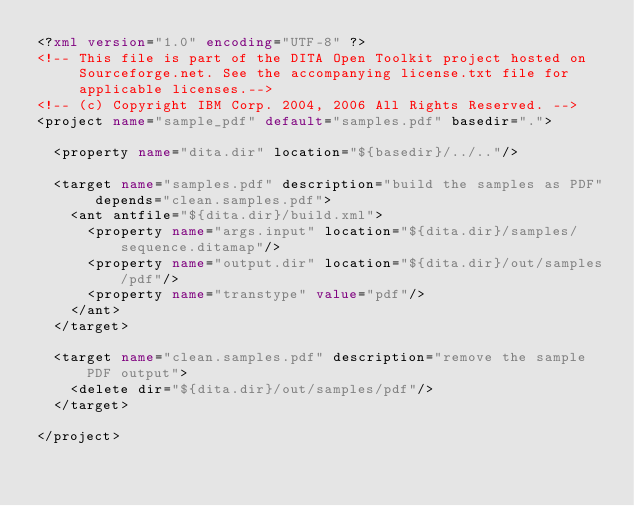Convert code to text. <code><loc_0><loc_0><loc_500><loc_500><_XML_><?xml version="1.0" encoding="UTF-8" ?>
<!-- This file is part of the DITA Open Toolkit project hosted on 
     Sourceforge.net. See the accompanying license.txt file for 
     applicable licenses.-->
<!-- (c) Copyright IBM Corp. 2004, 2006 All Rights Reserved. -->
<project name="sample_pdf" default="samples.pdf" basedir=".">
  
  <property name="dita.dir" location="${basedir}/../.."/>
  
  <target name="samples.pdf" description="build the samples as PDF" depends="clean.samples.pdf">
    <ant antfile="${dita.dir}/build.xml">
      <property name="args.input" location="${dita.dir}/samples/sequence.ditamap"/>
      <property name="output.dir" location="${dita.dir}/out/samples/pdf"/>
      <property name="transtype" value="pdf"/>
    </ant>
  </target>
  
  <target name="clean.samples.pdf" description="remove the sample PDF output">
    <delete dir="${dita.dir}/out/samples/pdf"/>
  </target>
  
</project>
</code> 